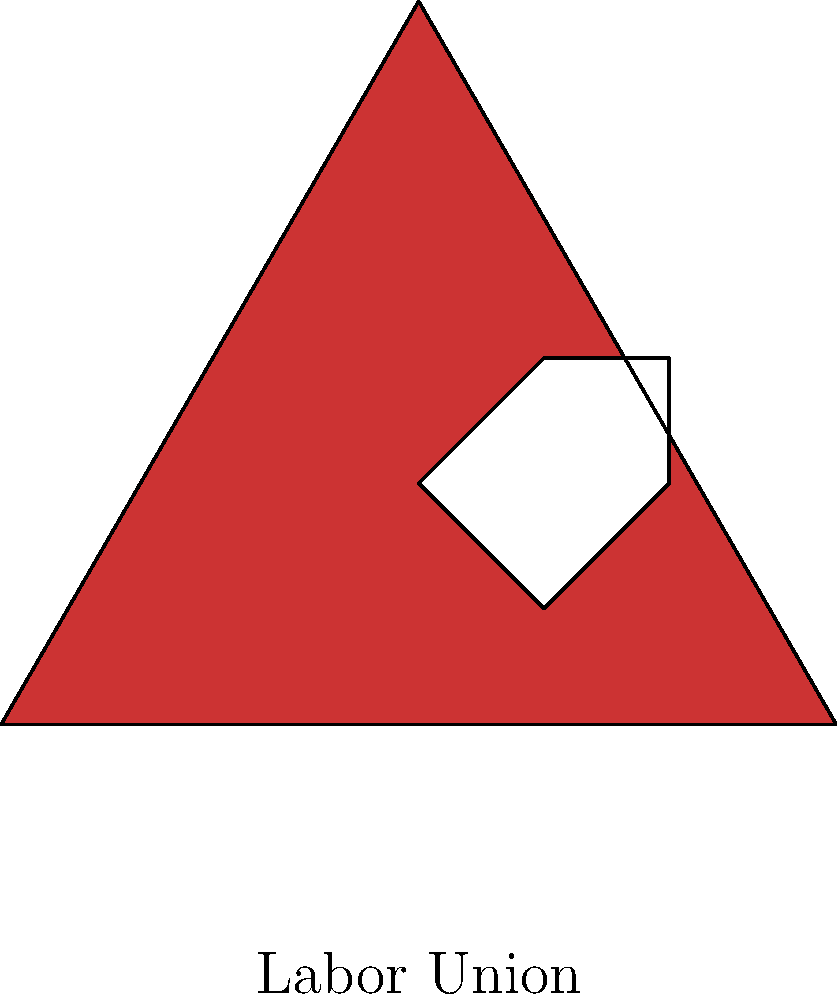A labor union has designed a logo consisting of a red equilateral triangle with a white fist symbol inside. If the logo is rotated $120^\circ$ counterclockwise around its center, how many times will it coincide with its original position during one full rotation (360°)? To solve this problem, we need to understand the concept of rotational symmetry:

1. An equilateral triangle has 3-fold rotational symmetry, meaning it coincides with itself three times during a full 360° rotation.

2. The rotation angles at which the triangle coincides with itself are:
   $0^\circ$ (original position)
   $120^\circ$ (1/3 of a full rotation)
   $240^\circ$ (2/3 of a full rotation)

3. The fist symbol inside the triangle is positioned in such a way that it also follows the 3-fold rotational symmetry of the triangle.

4. Therefore, the entire logo (triangle + fist) will coincide with its original position three times during one full rotation:
   - At $0^\circ$ (start/end position)
   - At $120^\circ$
   - At $240^\circ$

5. The question specifically asks about a $120^\circ$ counterclockwise rotation, which is one of the angles at which the logo coincides with its original position.

Thus, during one full rotation (360°), the logo will coincide with its original position 3 times.
Answer: 3 times 